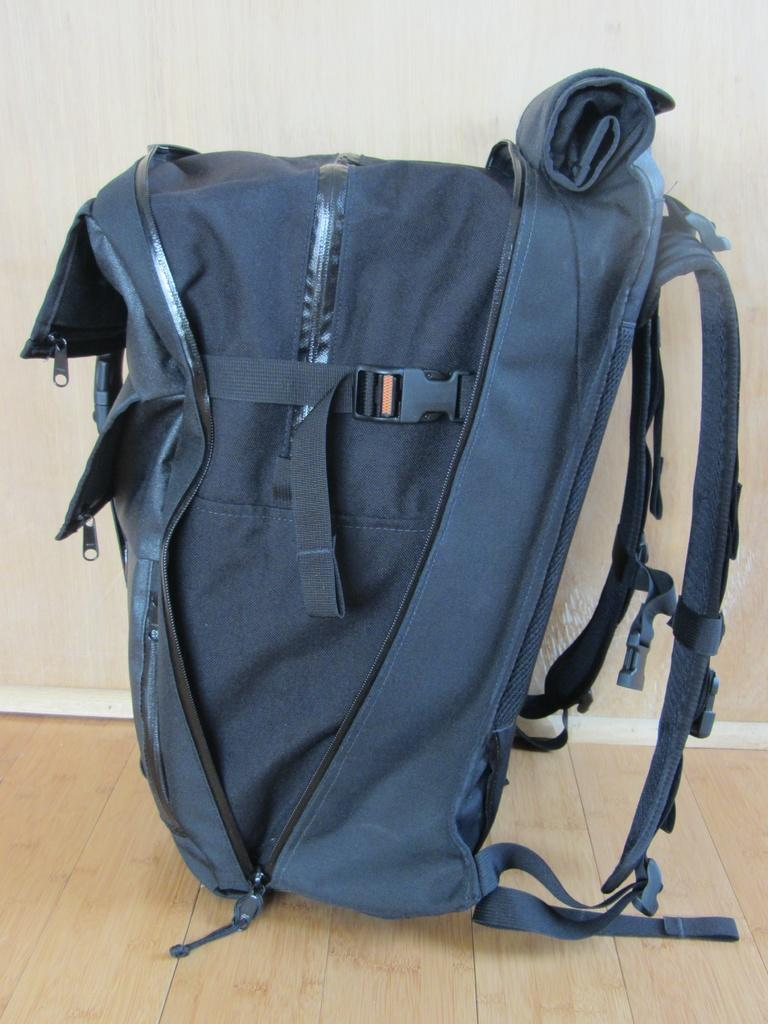What color is the bag that is visible in the image? The bag is blue in color. Where is the bag located in the image? The bag is on the floor in the image. What can be seen in the background of the image? There is a wall in the background of the image. How does the society benefit from the power generated by the dock in the image? There is no dock or power generation mentioned in the image; it only features a blue color bag on the floor and a wall in the background. 